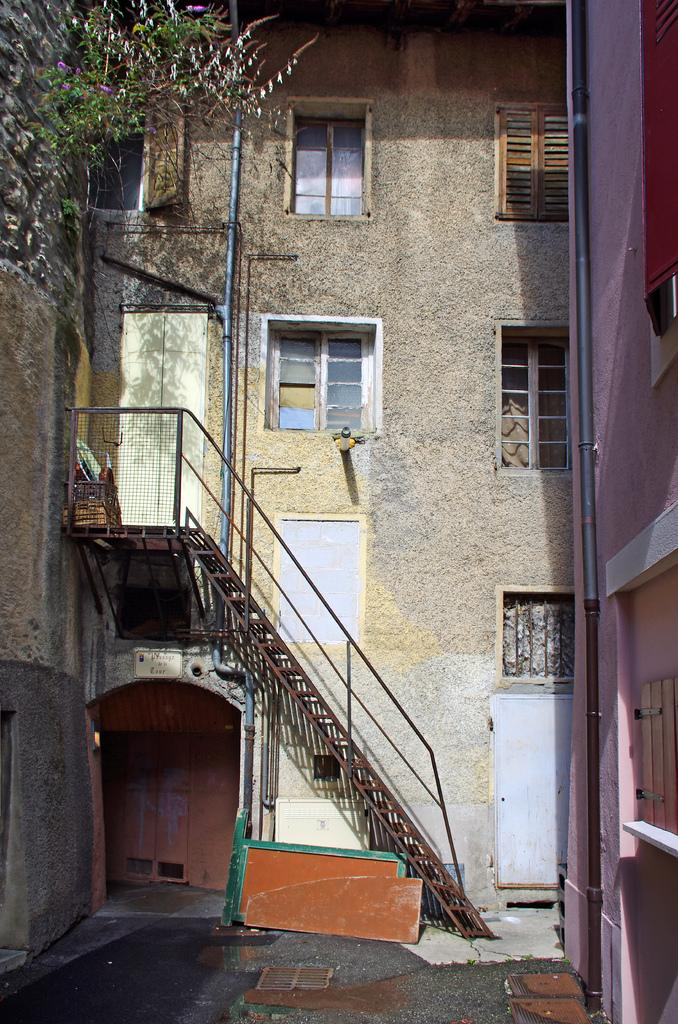What type of buildings are visible in the image? There are buildings with glass windows in the image. Can you describe any architectural features in the image? Yes, there is a metal staircase in the image. Are there any plants visible in the image? Yes, there is a flower plant in one of the buildings. What song is being played by the flower plant in the image? There is no song being played by the flower plant in the image, as plants do not have the ability to play music. 